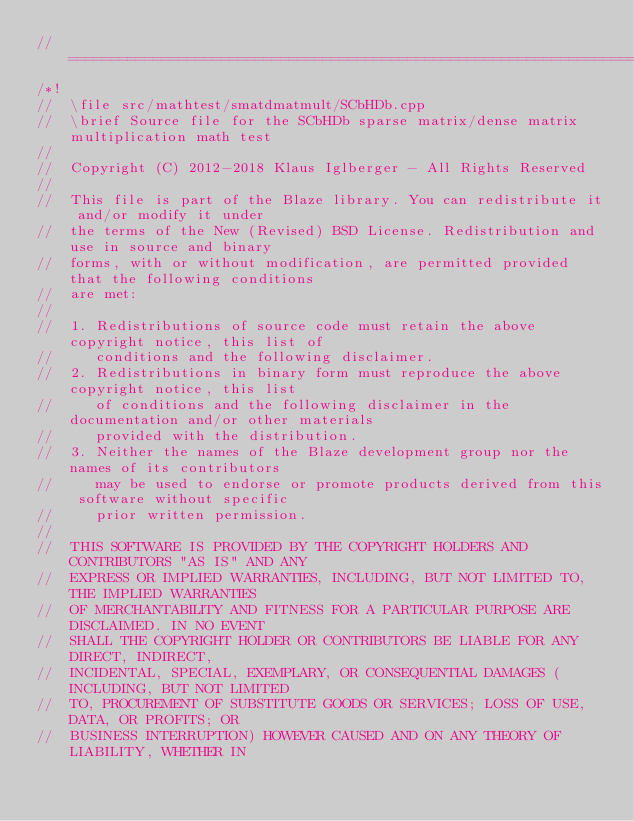Convert code to text. <code><loc_0><loc_0><loc_500><loc_500><_C++_>//=================================================================================================
/*!
//  \file src/mathtest/smatdmatmult/SCbHDb.cpp
//  \brief Source file for the SCbHDb sparse matrix/dense matrix multiplication math test
//
//  Copyright (C) 2012-2018 Klaus Iglberger - All Rights Reserved
//
//  This file is part of the Blaze library. You can redistribute it and/or modify it under
//  the terms of the New (Revised) BSD License. Redistribution and use in source and binary
//  forms, with or without modification, are permitted provided that the following conditions
//  are met:
//
//  1. Redistributions of source code must retain the above copyright notice, this list of
//     conditions and the following disclaimer.
//  2. Redistributions in binary form must reproduce the above copyright notice, this list
//     of conditions and the following disclaimer in the documentation and/or other materials
//     provided with the distribution.
//  3. Neither the names of the Blaze development group nor the names of its contributors
//     may be used to endorse or promote products derived from this software without specific
//     prior written permission.
//
//  THIS SOFTWARE IS PROVIDED BY THE COPYRIGHT HOLDERS AND CONTRIBUTORS "AS IS" AND ANY
//  EXPRESS OR IMPLIED WARRANTIES, INCLUDING, BUT NOT LIMITED TO, THE IMPLIED WARRANTIES
//  OF MERCHANTABILITY AND FITNESS FOR A PARTICULAR PURPOSE ARE DISCLAIMED. IN NO EVENT
//  SHALL THE COPYRIGHT HOLDER OR CONTRIBUTORS BE LIABLE FOR ANY DIRECT, INDIRECT,
//  INCIDENTAL, SPECIAL, EXEMPLARY, OR CONSEQUENTIAL DAMAGES (INCLUDING, BUT NOT LIMITED
//  TO, PROCUREMENT OF SUBSTITUTE GOODS OR SERVICES; LOSS OF USE, DATA, OR PROFITS; OR
//  BUSINESS INTERRUPTION) HOWEVER CAUSED AND ON ANY THEORY OF LIABILITY, WHETHER IN</code> 